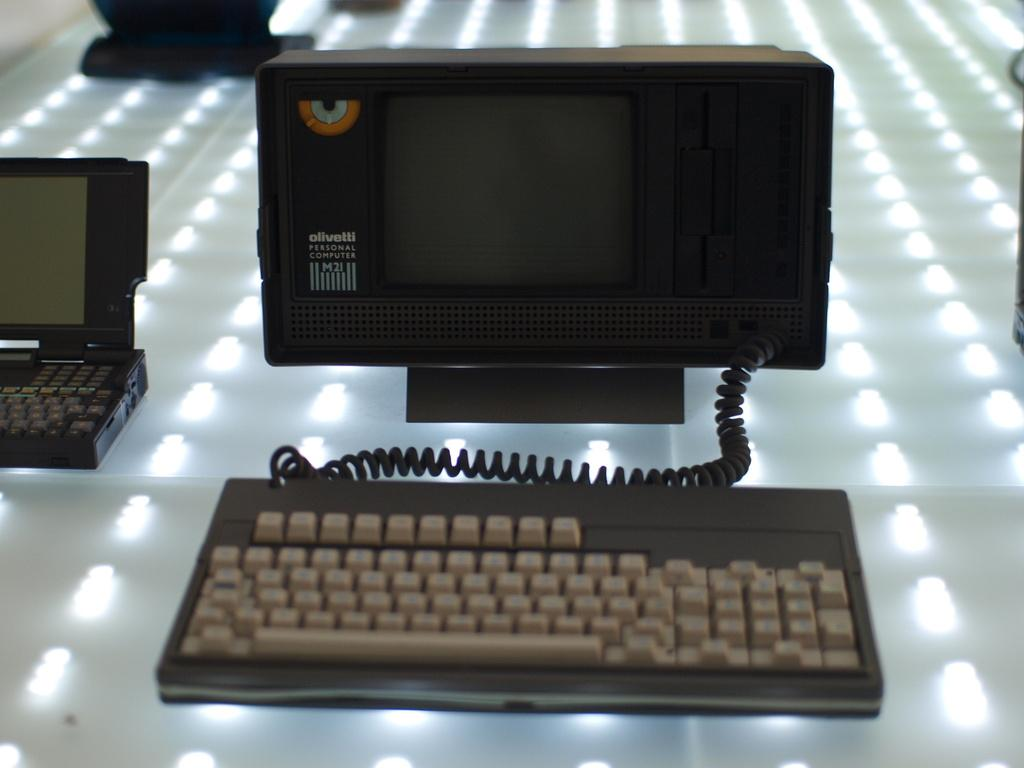<image>
Provide a brief description of the given image. An Olivetti personal computer has a monitor smaller than the keyboard. 